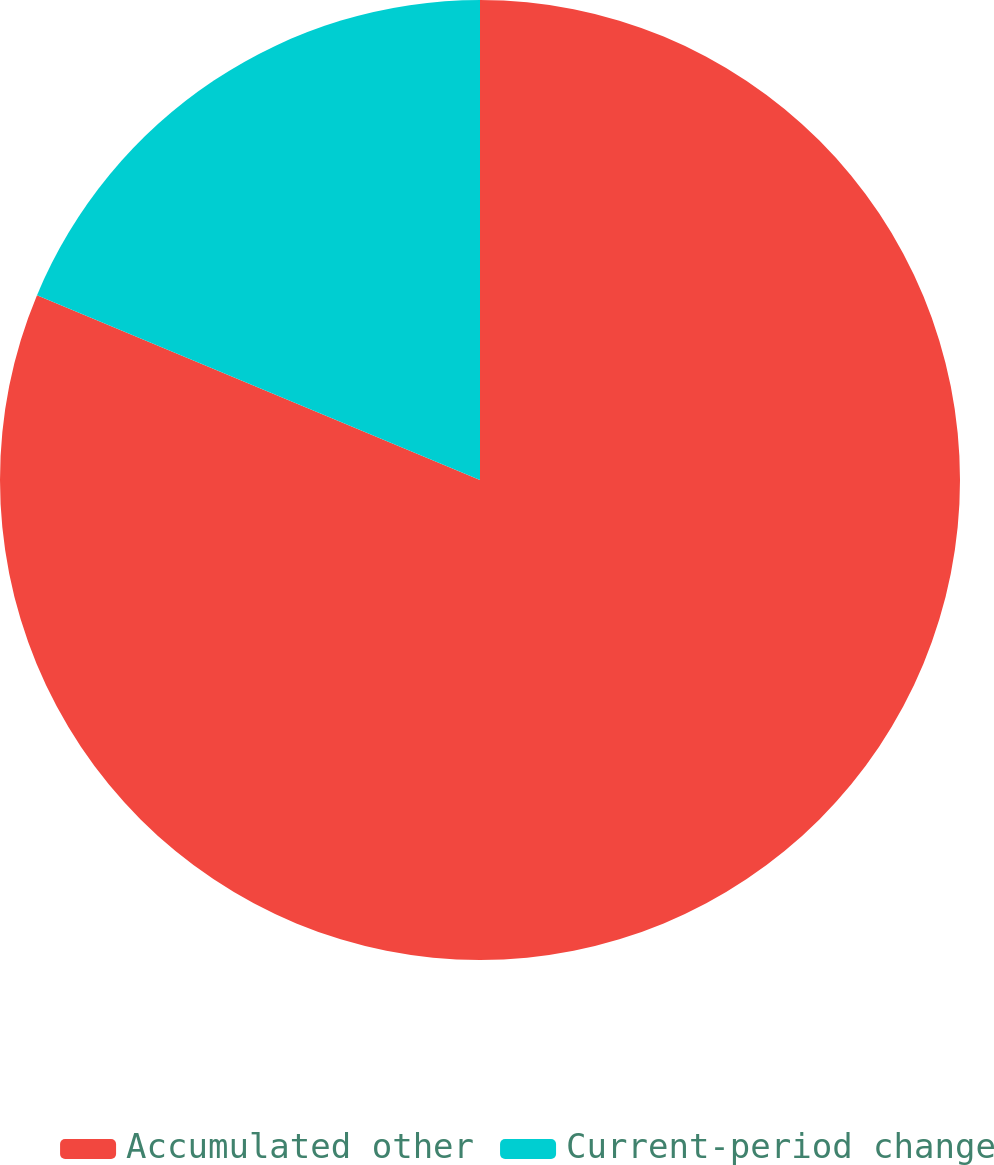Convert chart to OTSL. <chart><loc_0><loc_0><loc_500><loc_500><pie_chart><fcel>Accumulated other<fcel>Current-period change<nl><fcel>81.29%<fcel>18.71%<nl></chart> 